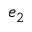Convert formula to latex. <formula><loc_0><loc_0><loc_500><loc_500>e _ { 2 }</formula> 